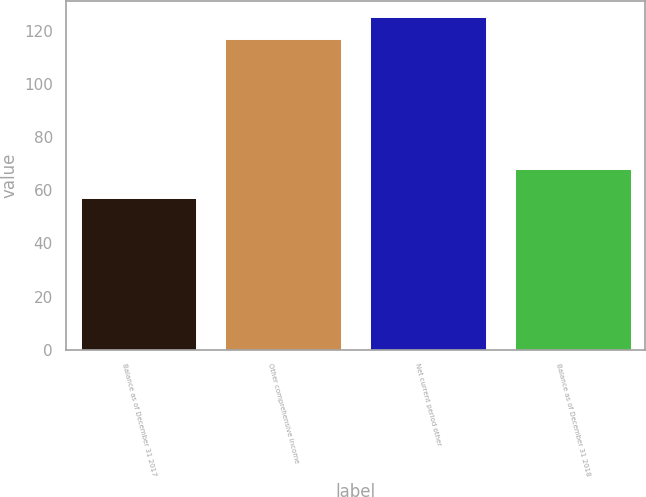Convert chart to OTSL. <chart><loc_0><loc_0><loc_500><loc_500><bar_chart><fcel>Balance as of December 31 2017<fcel>Other comprehensive income<fcel>Net current period other<fcel>Balance as of December 31 2018<nl><fcel>57<fcel>117<fcel>125<fcel>68<nl></chart> 